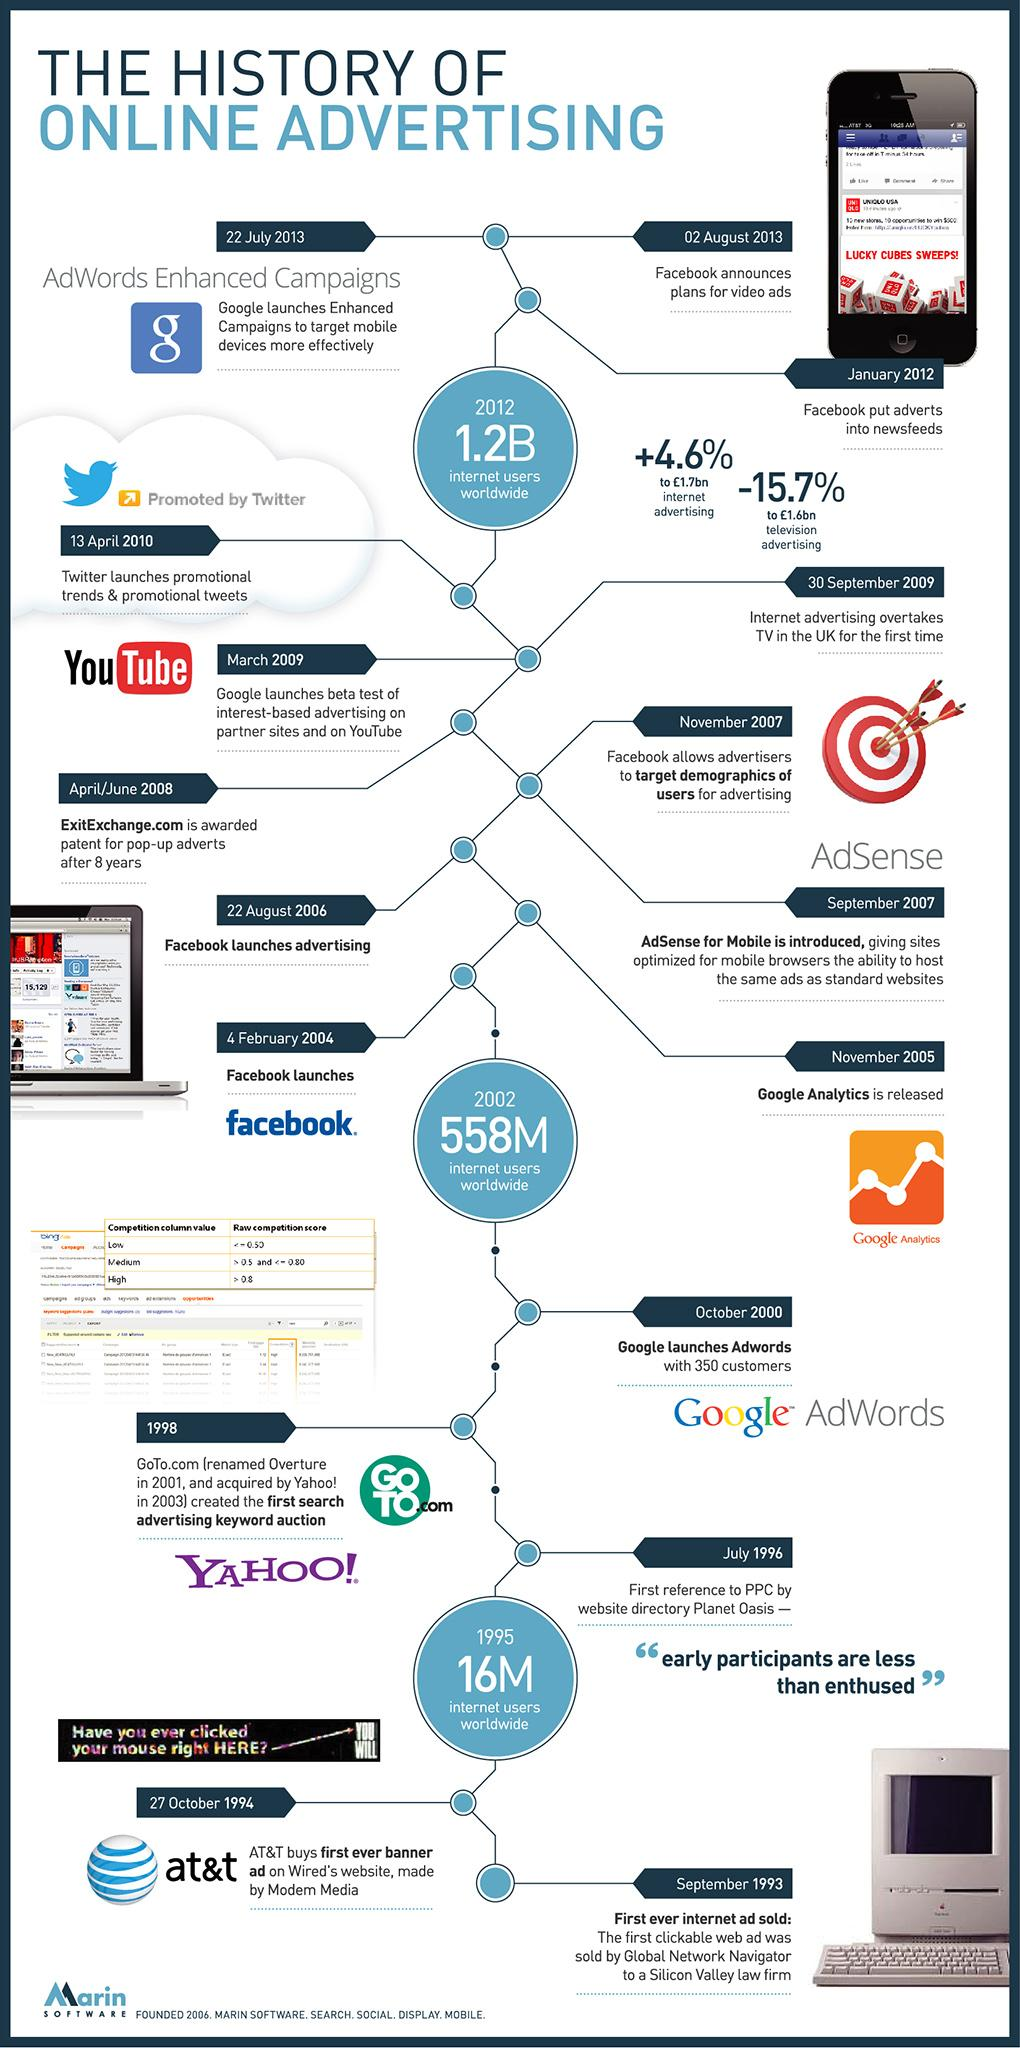Specify some key components in this picture. Facebook was introduced on February 4, 2004. In 2002, the global internet user population reached 558 million people. 